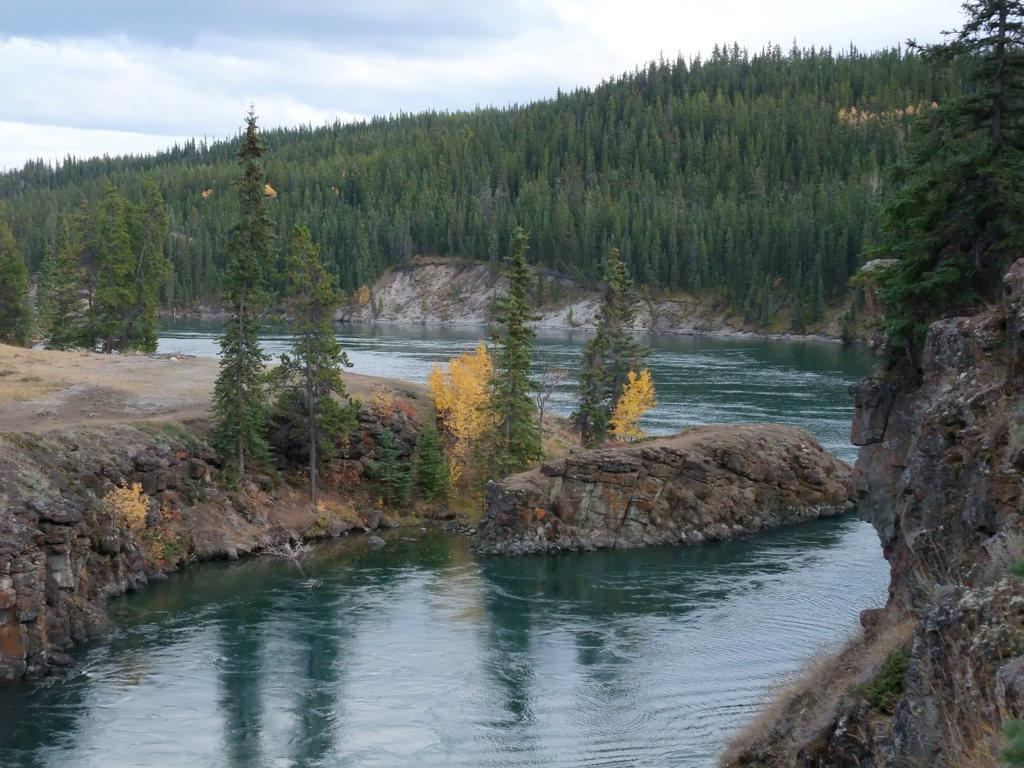What type of vegetation is present in the image? There are many trees in the image. What is visible at the top of the image? The sky is visible at the top of the image. What can be seen in the sky? There are clouds in the sky. What body of water is present at the bottom of the image? There is a lake at the bottom of the image. Where is the scarecrow standing in the image? There is no scarecrow present in the image. What type of pleasure can be experienced by the lake in the image? The image does not convey any information about the pleasure that can be experienced by the lake. 